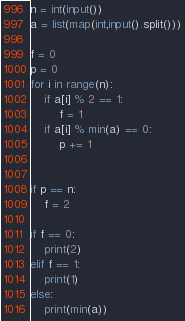Convert code to text. <code><loc_0><loc_0><loc_500><loc_500><_Python_>n = int(input())
a = list(map(int,input().split()))

f = 0
p = 0
for i in range(n):
    if a[i] % 2 == 1:
        f = 1
    if a[i] % min(a) == 0:
        p += 1


if p == n:
    f = 2

if f == 0:
    print(2)
elif f == 1:
    print(1)
else:
    print(min(a))
</code> 